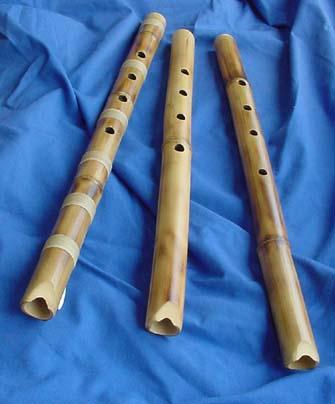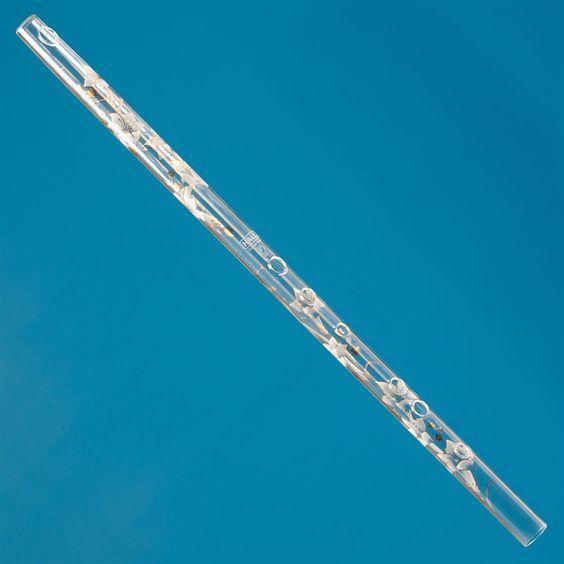The first image is the image on the left, the second image is the image on the right. Considering the images on both sides, is "The left image contains at least three flute like musical instruments." valid? Answer yes or no. Yes. The first image is the image on the left, the second image is the image on the right. Considering the images on both sides, is "There are more than three flutes." valid? Answer yes or no. Yes. 